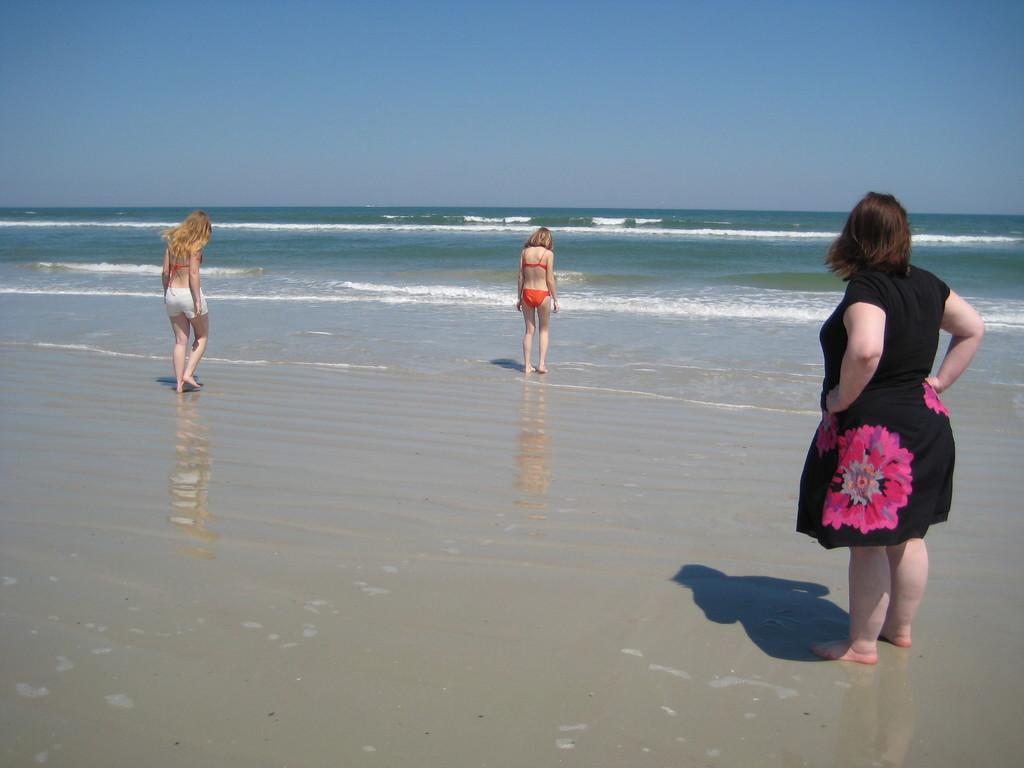Can you describe this image briefly? This image is clicked near the beach where there are three women standing on the sand. IN front of them there are waves. At the top there is the sky. 